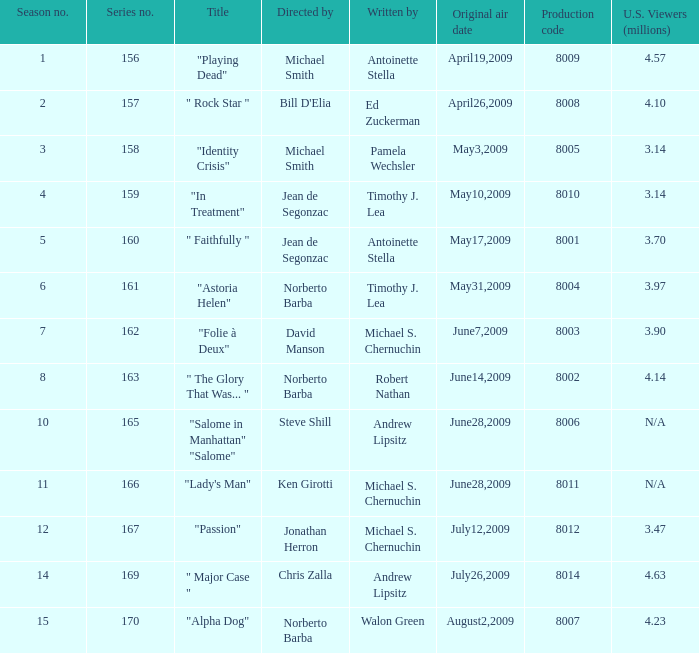14 million north american spectators? 159.0. 